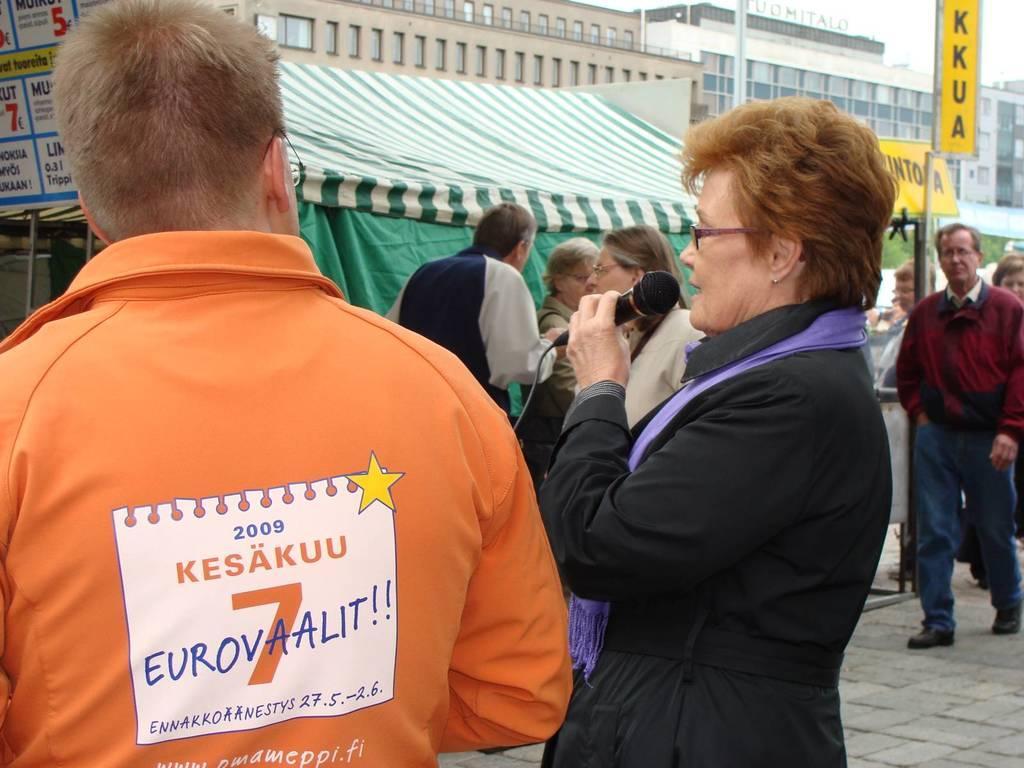In one or two sentences, can you explain what this image depicts? In this picture there is a lady on the right side of the image, by holding a mic in her hand and there is a boy on the left side of the image and there are other people in the background area of the image and there are posters, buildings and a stall in the background area of the image, there is a sign pole on the right side of the image. 